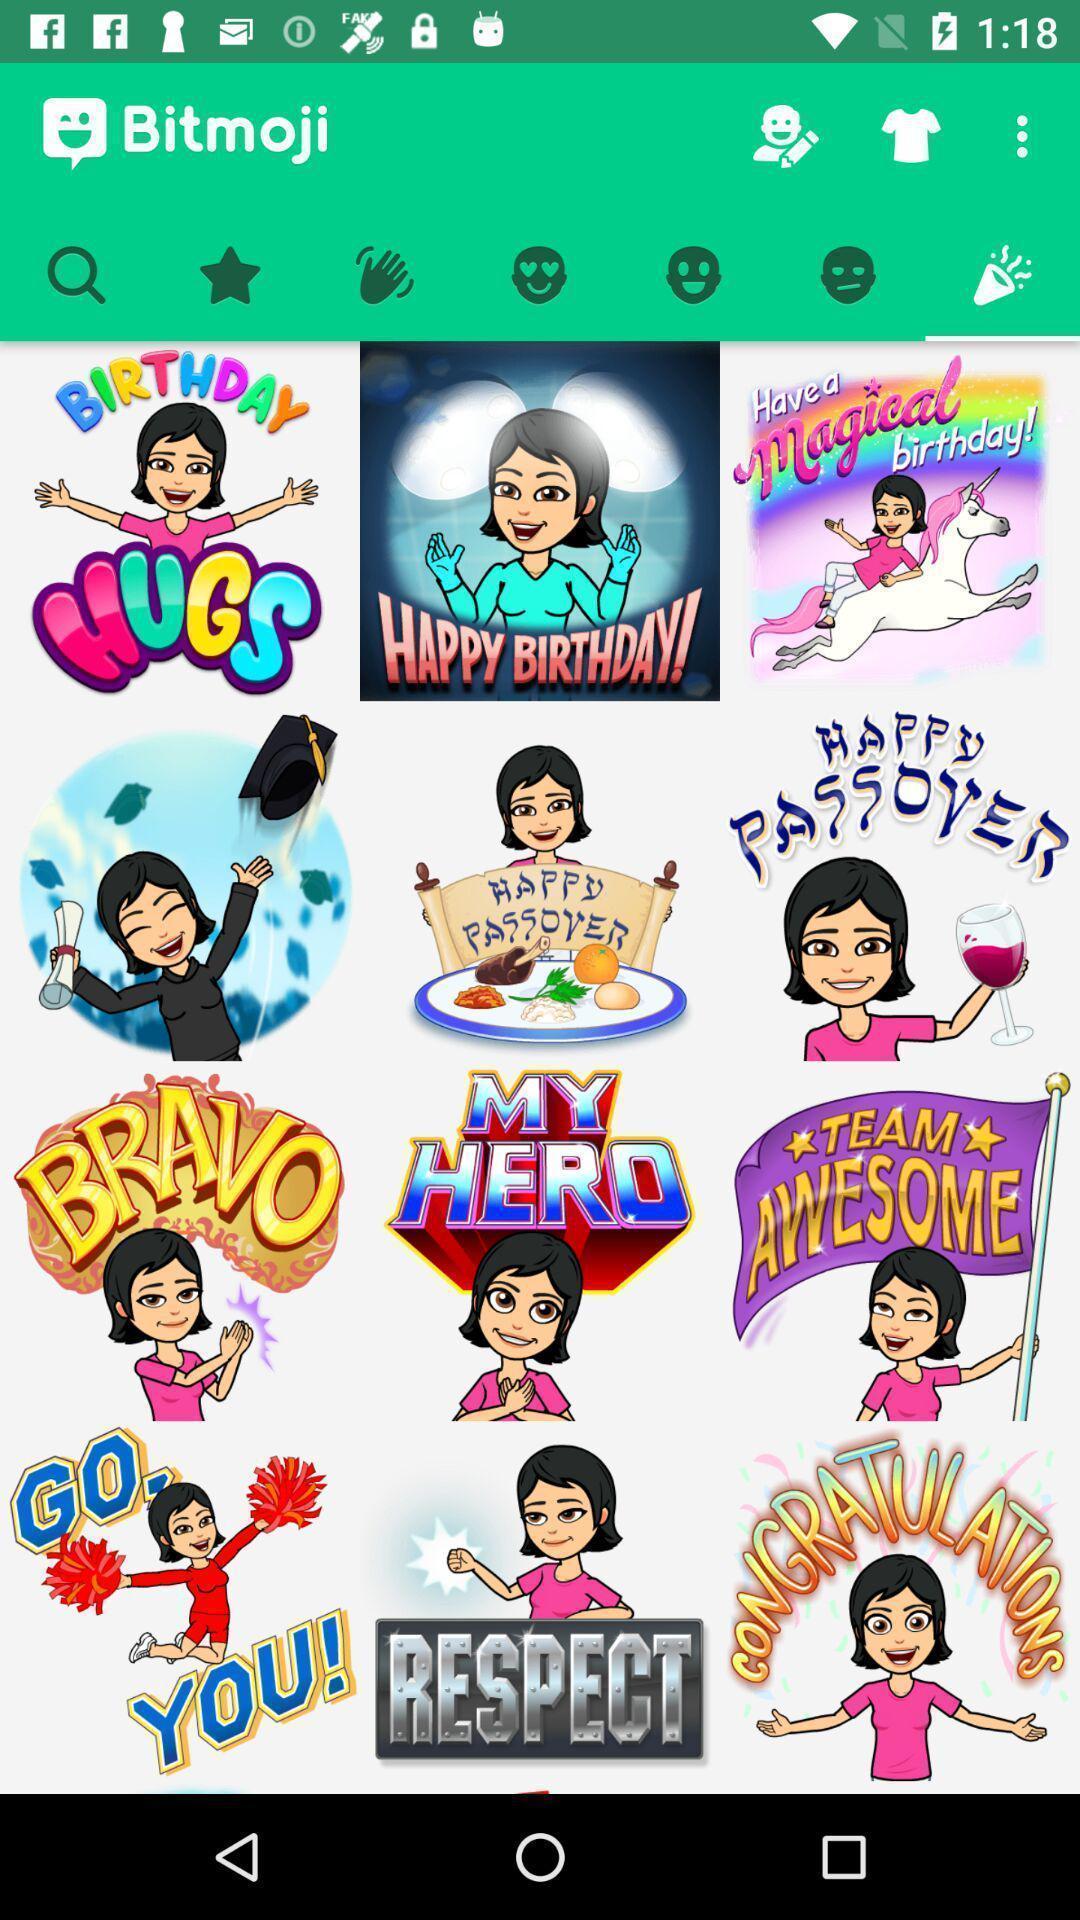Provide a detailed account of this screenshot. Screen shows different images. 